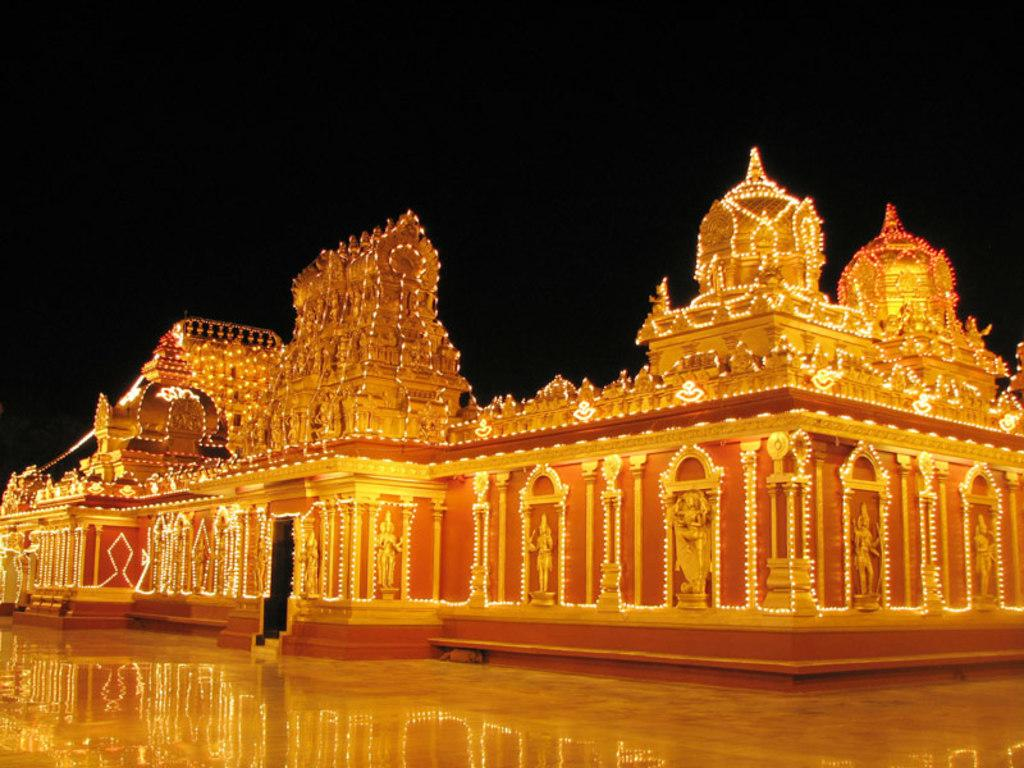What type of building is in the image? There is a temple in the image. How is the temple decorated? The temple is decorated with lights. What can be found on the temple? There are sculptures on the temple. Where is the coil located in the image? There is no coil present in the image. Can you see a pocket on the temple in the image? There is no pocket present on the temple in the image. 